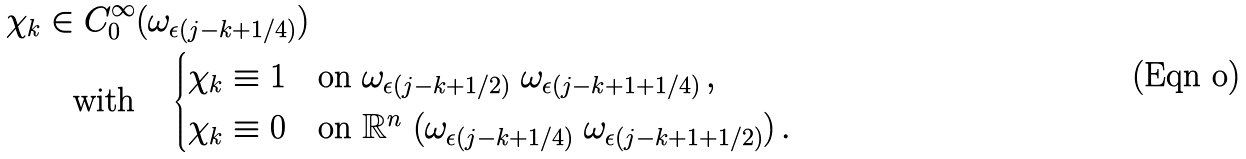Convert formula to latex. <formula><loc_0><loc_0><loc_500><loc_500>\chi _ { k } & \in C ^ { \infty } _ { 0 } ( \omega _ { \epsilon ( j - k + 1 / 4 ) } ) \\ & \quad \text {with} \quad \begin{cases} \chi _ { k } \equiv 1 & \text {on $\omega_{\epsilon(j-k+1/2)}\    \omega_{\epsilon(j-k+1+1/4)}\,,$} \\ \chi _ { k } \equiv 0 & \text {on $\mathbb{R}^{n} \ (    \omega_{\epsilon(j-k+1/4)}\    \omega_{\epsilon(j-k+1+1/2)})\,.$} \end{cases}</formula> 